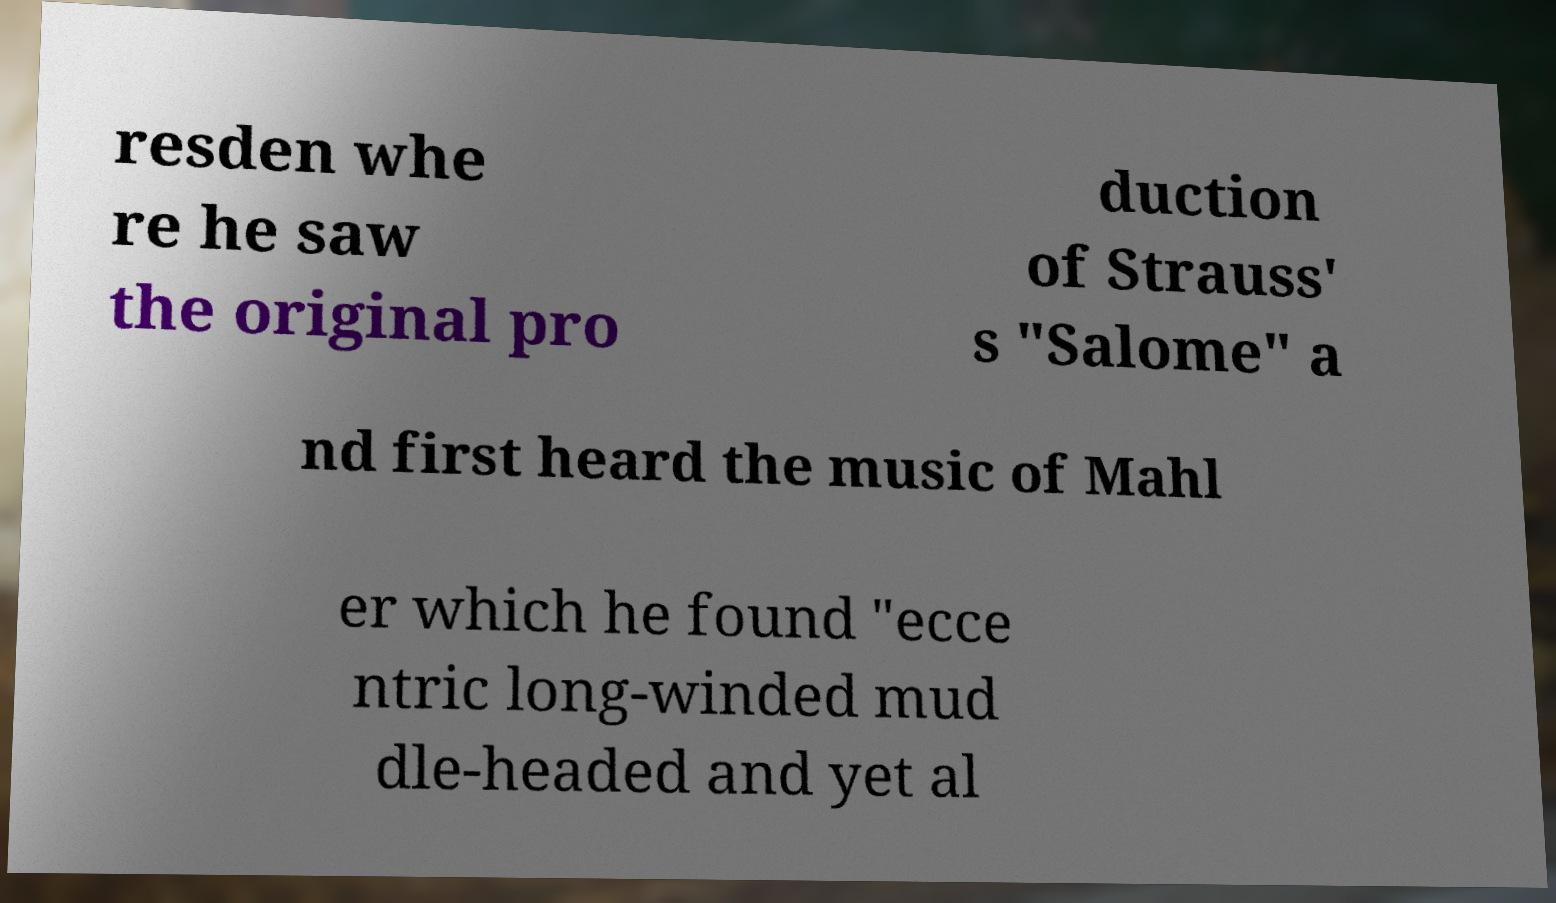Could you extract and type out the text from this image? resden whe re he saw the original pro duction of Strauss' s "Salome" a nd first heard the music of Mahl er which he found "ecce ntric long-winded mud dle-headed and yet al 